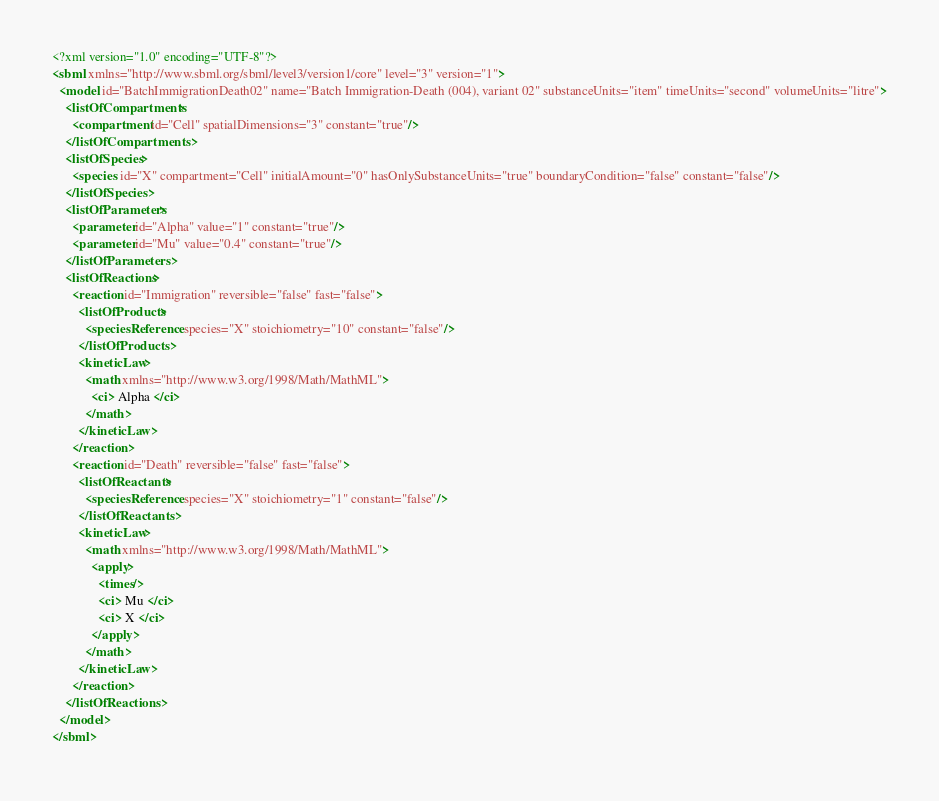<code> <loc_0><loc_0><loc_500><loc_500><_XML_><?xml version="1.0" encoding="UTF-8"?>
<sbml xmlns="http://www.sbml.org/sbml/level3/version1/core" level="3" version="1">
  <model id="BatchImmigrationDeath02" name="Batch Immigration-Death (004), variant 02" substanceUnits="item" timeUnits="second" volumeUnits="litre">
    <listOfCompartments>
      <compartment id="Cell" spatialDimensions="3" constant="true"/>
    </listOfCompartments>
    <listOfSpecies>
      <species id="X" compartment="Cell" initialAmount="0" hasOnlySubstanceUnits="true" boundaryCondition="false" constant="false"/>
    </listOfSpecies>
    <listOfParameters>
      <parameter id="Alpha" value="1" constant="true"/>
      <parameter id="Mu" value="0.4" constant="true"/>
    </listOfParameters>
    <listOfReactions>
      <reaction id="Immigration" reversible="false" fast="false">
        <listOfProducts>
          <speciesReference species="X" stoichiometry="10" constant="false"/>
        </listOfProducts>
        <kineticLaw>
          <math xmlns="http://www.w3.org/1998/Math/MathML">
            <ci> Alpha </ci>
          </math>
        </kineticLaw>
      </reaction>
      <reaction id="Death" reversible="false" fast="false">
        <listOfReactants>
          <speciesReference species="X" stoichiometry="1" constant="false"/>
        </listOfReactants>
        <kineticLaw>
          <math xmlns="http://www.w3.org/1998/Math/MathML">
            <apply>
              <times/>
              <ci> Mu </ci>
              <ci> X </ci>
            </apply>
          </math>
        </kineticLaw>
      </reaction>
    </listOfReactions>
  </model>
</sbml>
</code> 